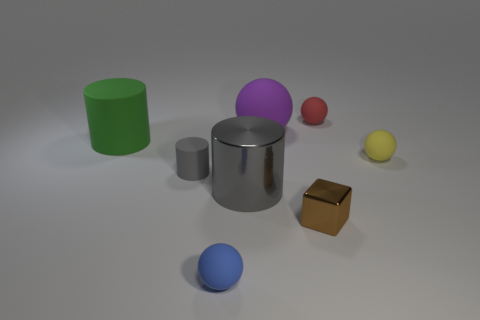Is the number of red objects that are behind the tiny brown cube the same as the number of small yellow spheres to the left of the red ball?
Ensure brevity in your answer.  No. Are there more tiny purple matte spheres than matte cylinders?
Offer a terse response. No. What number of metallic things are either brown cubes or gray cylinders?
Give a very brief answer. 2. How many rubber spheres are the same color as the big matte cylinder?
Provide a succinct answer. 0. What material is the gray cylinder to the right of the tiny gray matte thing that is right of the large green rubber cylinder behind the small brown metallic object made of?
Make the answer very short. Metal. The big cylinder to the right of the tiny ball in front of the brown shiny block is what color?
Offer a very short reply. Gray. What number of tiny objects are cyan metallic spheres or gray metal objects?
Give a very brief answer. 0. What number of big purple things are the same material as the big green thing?
Keep it short and to the point. 1. What is the size of the matte object in front of the big gray cylinder?
Offer a terse response. Small. There is a small object behind the matte object right of the red matte thing; what is its shape?
Keep it short and to the point. Sphere. 